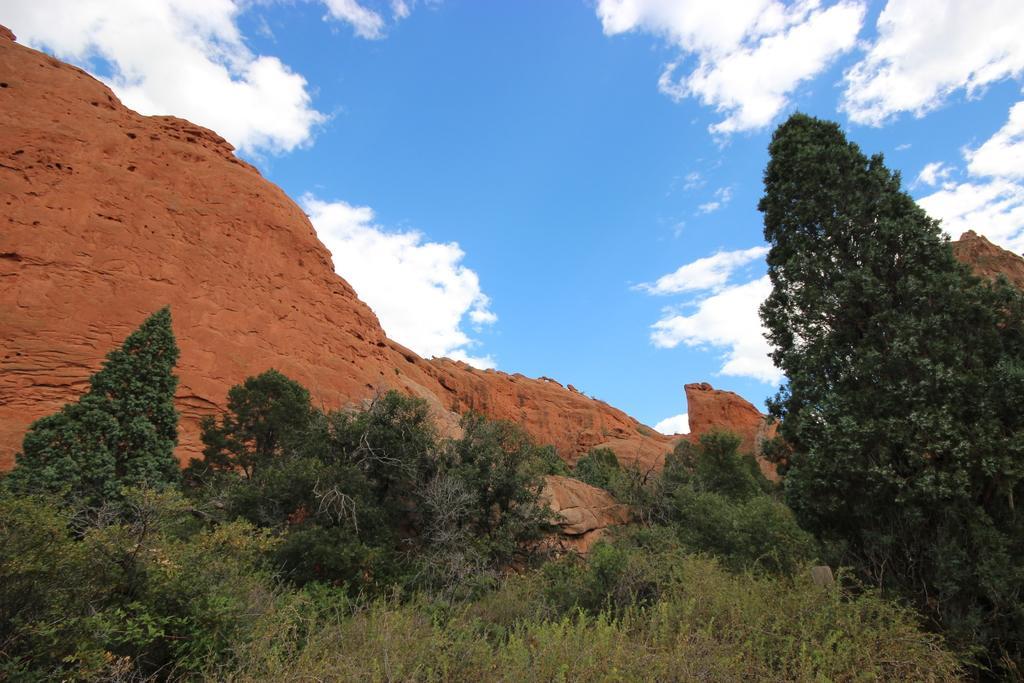Please provide a concise description of this image. In the foreground of the picture there are shrubs and trees. In the center of the picture there is a mountain. Sky is partially cloudy. 